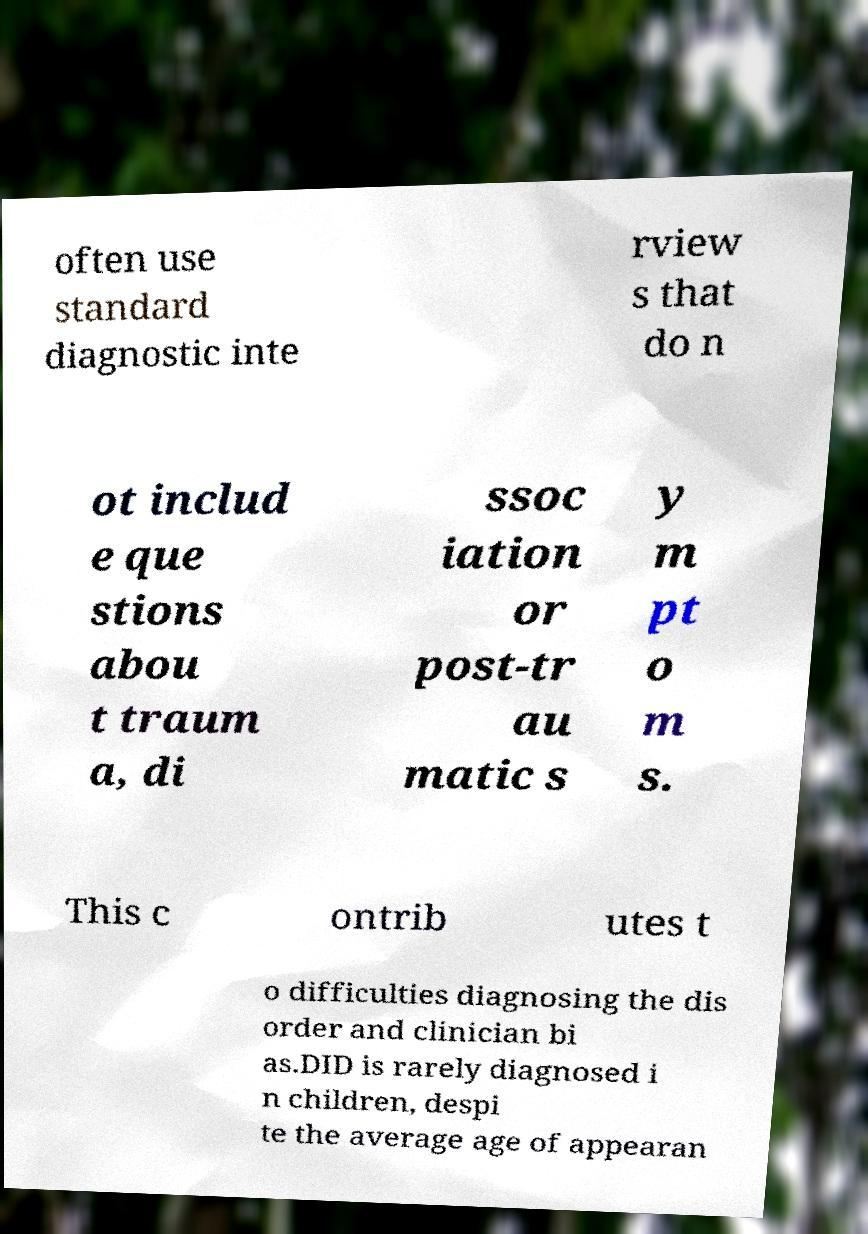For documentation purposes, I need the text within this image transcribed. Could you provide that? often use standard diagnostic inte rview s that do n ot includ e que stions abou t traum a, di ssoc iation or post-tr au matic s y m pt o m s. This c ontrib utes t o difficulties diagnosing the dis order and clinician bi as.DID is rarely diagnosed i n children, despi te the average age of appearan 